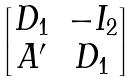Convert formula to latex. <formula><loc_0><loc_0><loc_500><loc_500>\begin{bmatrix} D _ { 1 } & - I _ { 2 } \\ A ^ { \prime } & D _ { 1 } \end{bmatrix}</formula> 